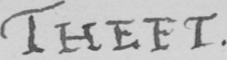What is written in this line of handwriting? THEFT 